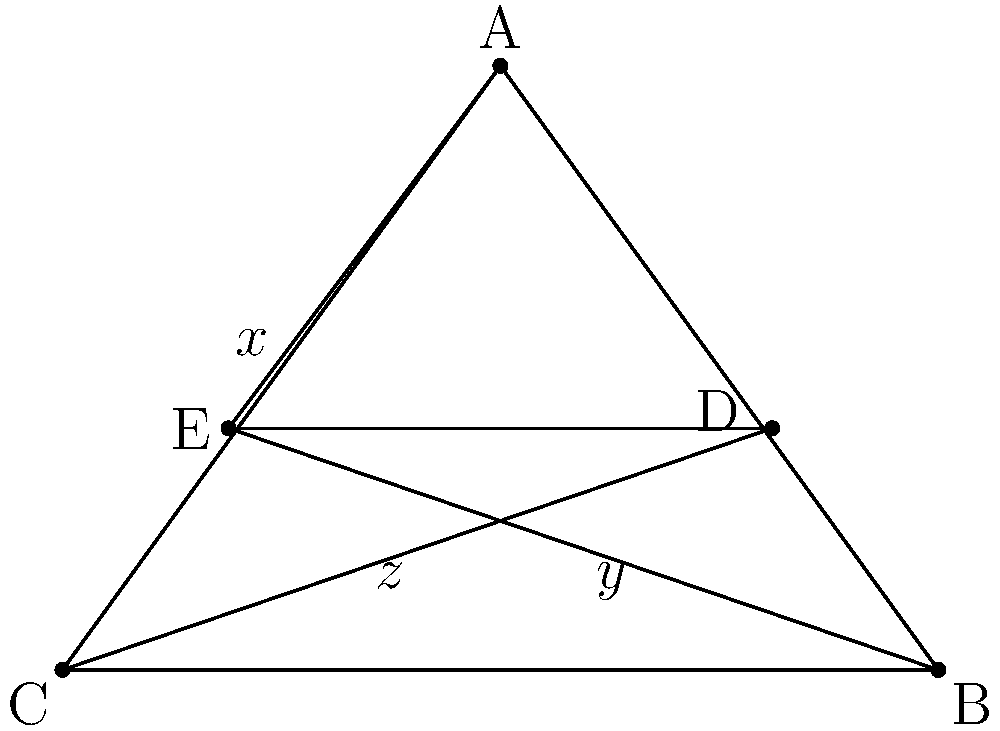In the star polygon above, representing different cultural perspectives in your identity, angles $x$, $y$, and $z$ are formed at the intersections of the lines. If the polygon is regular and $x = 36°$, calculate the values of $y$ and $z$. Let's approach this step-by-step:

1) In a regular star polygon, all angles at the points are equal. This means that $\angle BAC = \angle ABC = \angle BCA = 36°$.

2) In any triangle, the sum of all angles is 180°. So in triangle ABC:
   $36° + 36° + \angle ACB = 180°$
   $\angle ACB = 180° - 72° = 108°$

3) Angle $x$ is an alternate angle to $\angle ACB$, so $x = 108°$.

4) The star polygon is made up of 5 congruent triangles. The sum of angles in a pentagon is $(5-2) \times 180° = 540°$.

5) Each point of the star contributes $36°$ to this sum, so the remaining angle at each point is:
   $(540° - 5 \times 36°) \div 5 = 72°$

6) This $72°$ angle is divided into two parts by the lines forming $y$ and $z$. Since the polygon is regular, these parts are equal.

7) Therefore, $y = z = 72° \div 2 = 36°$

Thus, we've found that $y = 36°$ and $z = 36°$.
Answer: $y = 36°$, $z = 36°$ 